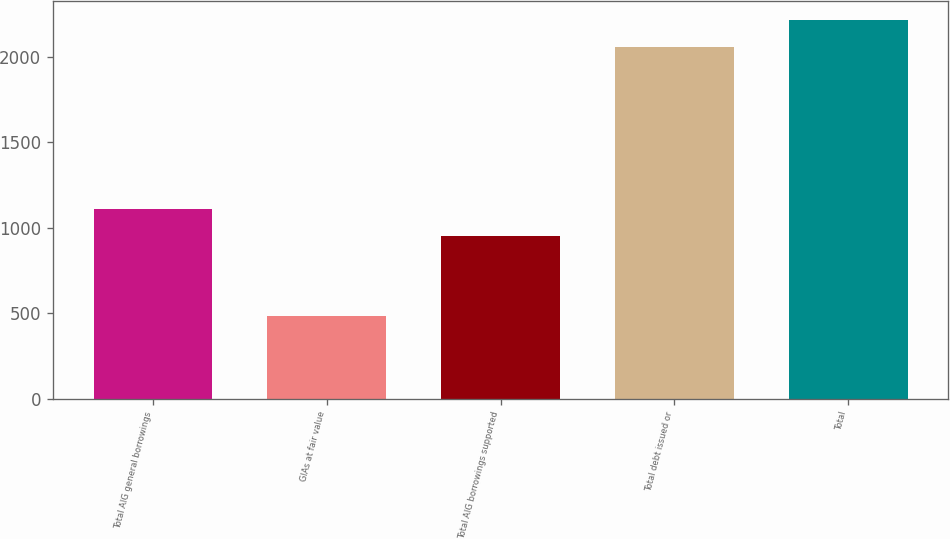<chart> <loc_0><loc_0><loc_500><loc_500><bar_chart><fcel>Total AIG general borrowings<fcel>GIAs at fair value<fcel>Total AIG borrowings supported<fcel>Total debt issued or<fcel>Total<nl><fcel>1107<fcel>486<fcel>950<fcel>2056<fcel>2213<nl></chart> 